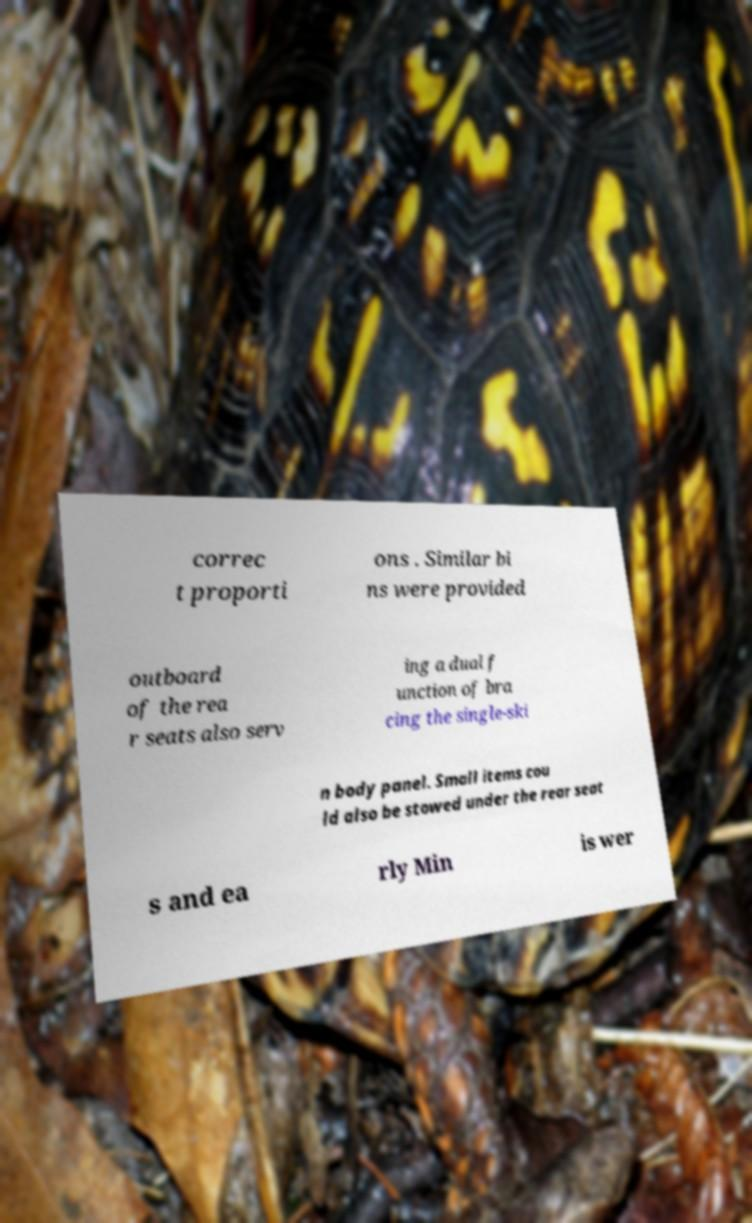There's text embedded in this image that I need extracted. Can you transcribe it verbatim? correc t proporti ons . Similar bi ns were provided outboard of the rea r seats also serv ing a dual f unction of bra cing the single-ski n body panel. Small items cou ld also be stowed under the rear seat s and ea rly Min is wer 